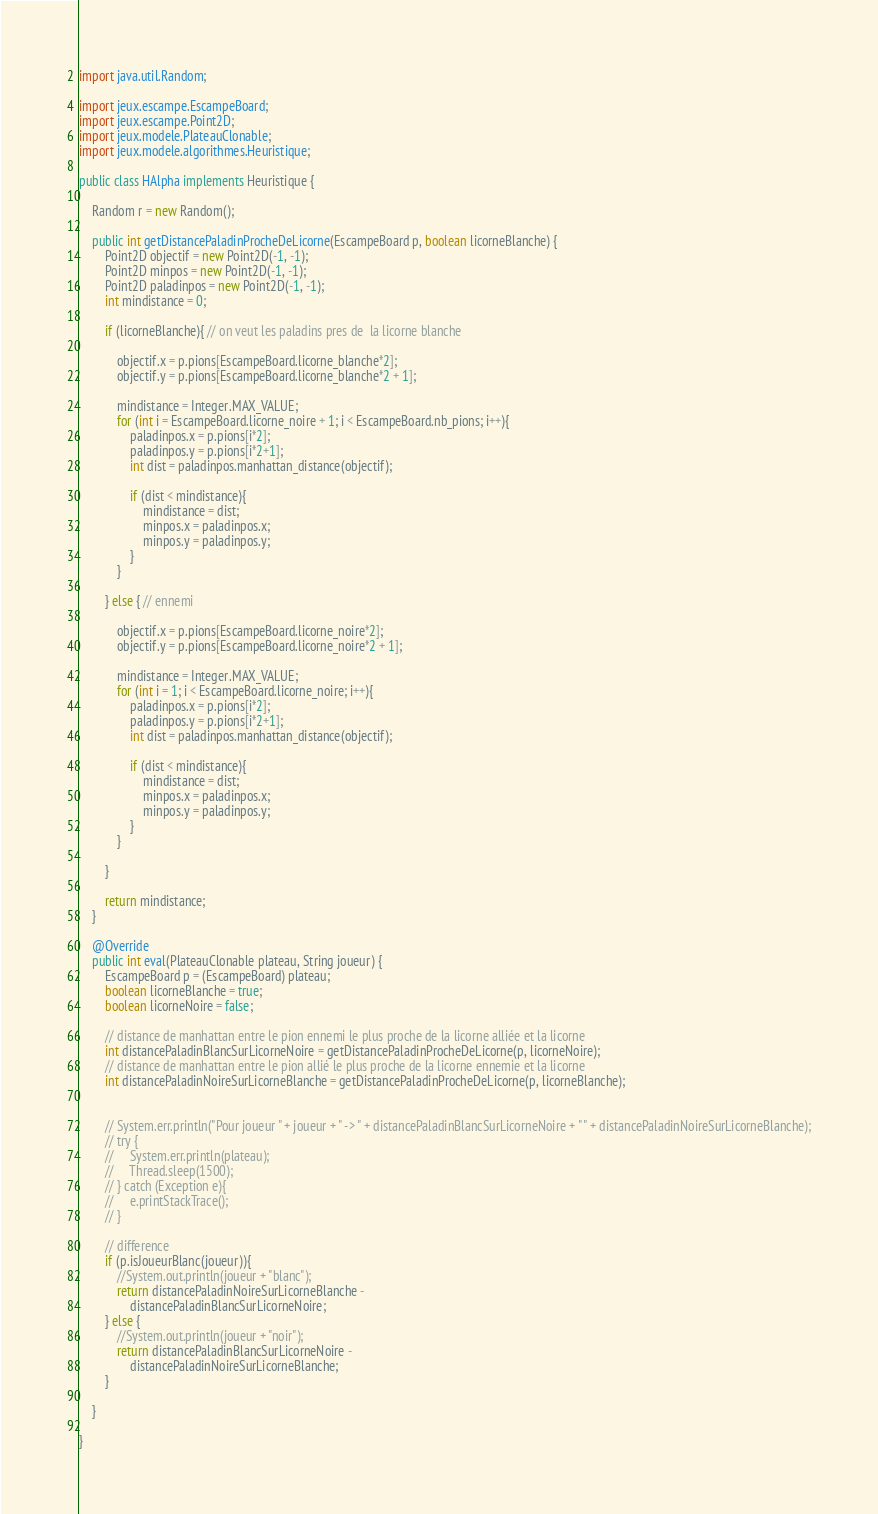Convert code to text. <code><loc_0><loc_0><loc_500><loc_500><_Java_>
import java.util.Random;

import jeux.escampe.EscampeBoard;
import jeux.escampe.Point2D;
import jeux.modele.PlateauClonable;
import jeux.modele.algorithmes.Heuristique;

public class HAlpha implements Heuristique {

    Random r = new Random();

    public int getDistancePaladinProcheDeLicorne(EscampeBoard p, boolean licorneBlanche) {
        Point2D objectif = new Point2D(-1, -1);
        Point2D minpos = new Point2D(-1, -1);
        Point2D paladinpos = new Point2D(-1, -1);
        int mindistance = 0;
    
        if (licorneBlanche){ // on veut les paladins pres de  la licorne blanche

            objectif.x = p.pions[EscampeBoard.licorne_blanche*2];
            objectif.y = p.pions[EscampeBoard.licorne_blanche*2 + 1];

            mindistance = Integer.MAX_VALUE;
            for (int i = EscampeBoard.licorne_noire + 1; i < EscampeBoard.nb_pions; i++){
                paladinpos.x = p.pions[i*2];
                paladinpos.y = p.pions[i*2+1];
                int dist = paladinpos.manhattan_distance(objectif);
                
                if (dist < mindistance){
                    mindistance = dist;
                    minpos.x = paladinpos.x;
                    minpos.y = paladinpos.y;
                }
            }

        } else { // ennemi

            objectif.x = p.pions[EscampeBoard.licorne_noire*2];
            objectif.y = p.pions[EscampeBoard.licorne_noire*2 + 1];
             
            mindistance = Integer.MAX_VALUE;
            for (int i = 1; i < EscampeBoard.licorne_noire; i++){
                paladinpos.x = p.pions[i*2];
                paladinpos.y = p.pions[i*2+1];
                int dist = paladinpos.manhattan_distance(objectif);
                
                if (dist < mindistance){
                    mindistance = dist;
                    minpos.x = paladinpos.x;
                    minpos.y = paladinpos.y;
                }
            }

        }

        return mindistance;
    }

    @Override
    public int eval(PlateauClonable plateau, String joueur) {
        EscampeBoard p = (EscampeBoard) plateau;
        boolean licorneBlanche = true;
        boolean licorneNoire = false;

        // distance de manhattan entre le pion ennemi le plus proche de la licorne alliée et la licorne
        int distancePaladinBlancSurLicorneNoire = getDistancePaladinProcheDeLicorne(p, licorneNoire);
        // distance de manhattan entre le pion allié le plus proche de la licorne ennemie et la licorne
        int distancePaladinNoireSurLicorneBlanche = getDistancePaladinProcheDeLicorne(p, licorneBlanche);

        
        // System.err.println("Pour joueur " + joueur + " -> " + distancePaladinBlancSurLicorneNoire + " " + distancePaladinNoireSurLicorneBlanche);
        // try {
        //     System.err.println(plateau);
        //     Thread.sleep(1500);
        // } catch (Exception e){
        //     e.printStackTrace();
        // }

        // difference
        if (p.isJoueurBlanc(joueur)){
            //System.out.println(joueur + "blanc");
            return distancePaladinNoireSurLicorneBlanche - 
                distancePaladinBlancSurLicorneNoire;
        } else {
            //System.out.println(joueur + "noir");
            return distancePaladinBlancSurLicorneNoire - 
                distancePaladinNoireSurLicorneBlanche;
        }
        
    }

}</code> 